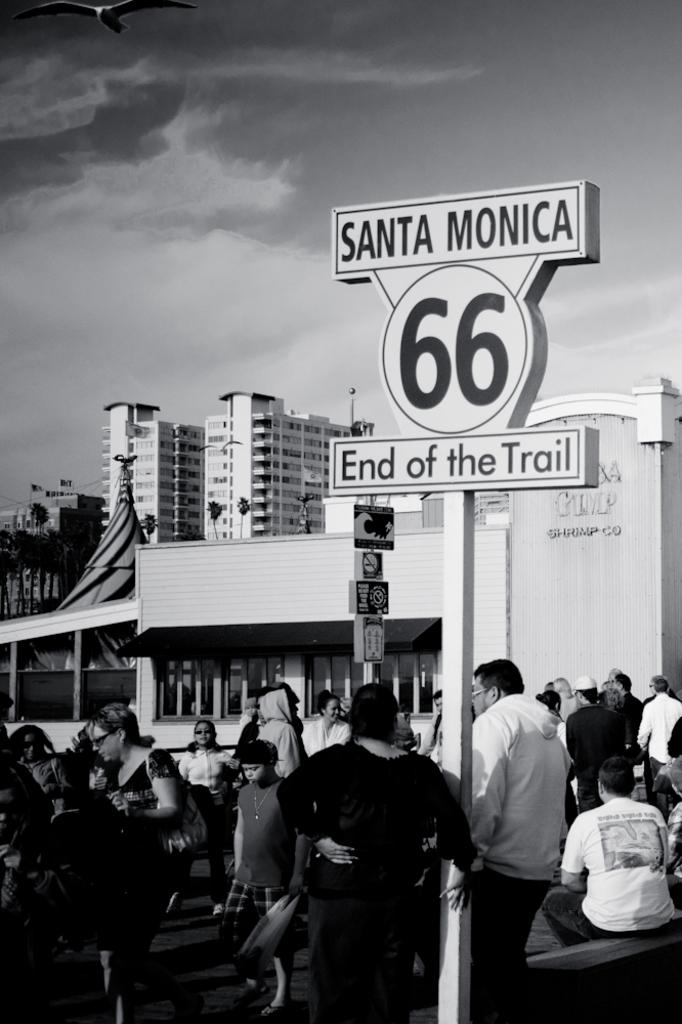What is the main object in the image? There is a sign board in the image. What is happening on the sign board? A man is standing on the sign board. What is the man wearing? The man is wearing a coat. Who is standing beside the man? There is a woman standing beside the man. Are there any other people in the image? Yes, there are other people present in the image. What can be seen in the background of the image? There are buildings visible at the top of the image. What type of quilt is being used to cover the carpenter in the image? There is no quilt or carpenter present in the image. What kind of flowers can be seen growing near the woman in the image? There are no flowers visible in the image. 